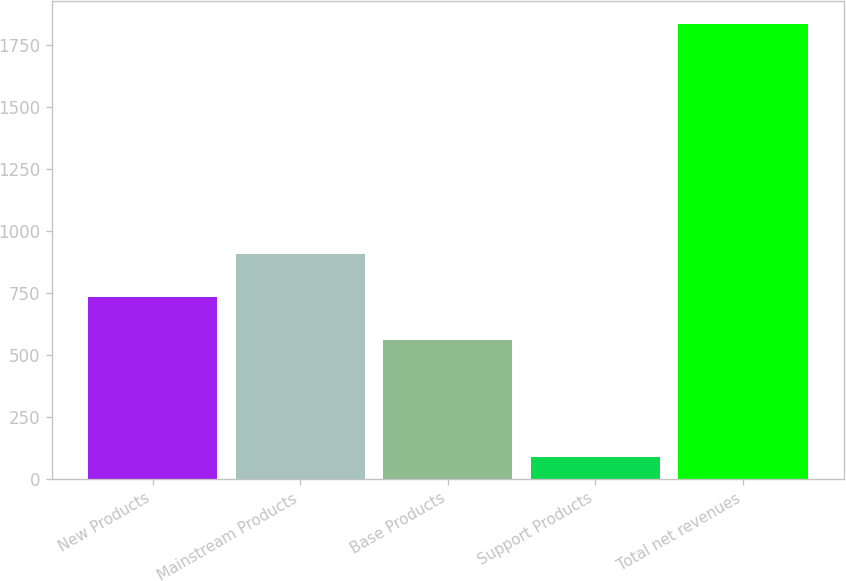<chart> <loc_0><loc_0><loc_500><loc_500><bar_chart><fcel>New Products<fcel>Mainstream Products<fcel>Base Products<fcel>Support Products<fcel>Total net revenues<nl><fcel>733.47<fcel>907.84<fcel>559.1<fcel>89.9<fcel>1833.6<nl></chart> 